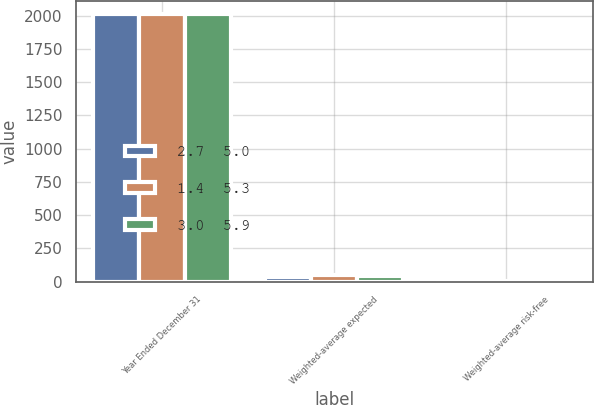Convert chart. <chart><loc_0><loc_0><loc_500><loc_500><stacked_bar_chart><ecel><fcel>Year Ended December 31<fcel>Weighted-average expected<fcel>Weighted-average risk-free<nl><fcel>2.7  5.0<fcel>2010<fcel>35<fcel>2.8<nl><fcel>1.4  5.3<fcel>2009<fcel>52<fcel>3<nl><fcel>3.0  5.9<fcel>2008<fcel>44<fcel>3.9<nl></chart> 